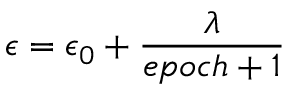Convert formula to latex. <formula><loc_0><loc_0><loc_500><loc_500>\epsilon = \epsilon _ { 0 } + \frac { \lambda } { e p o c h + 1 }</formula> 